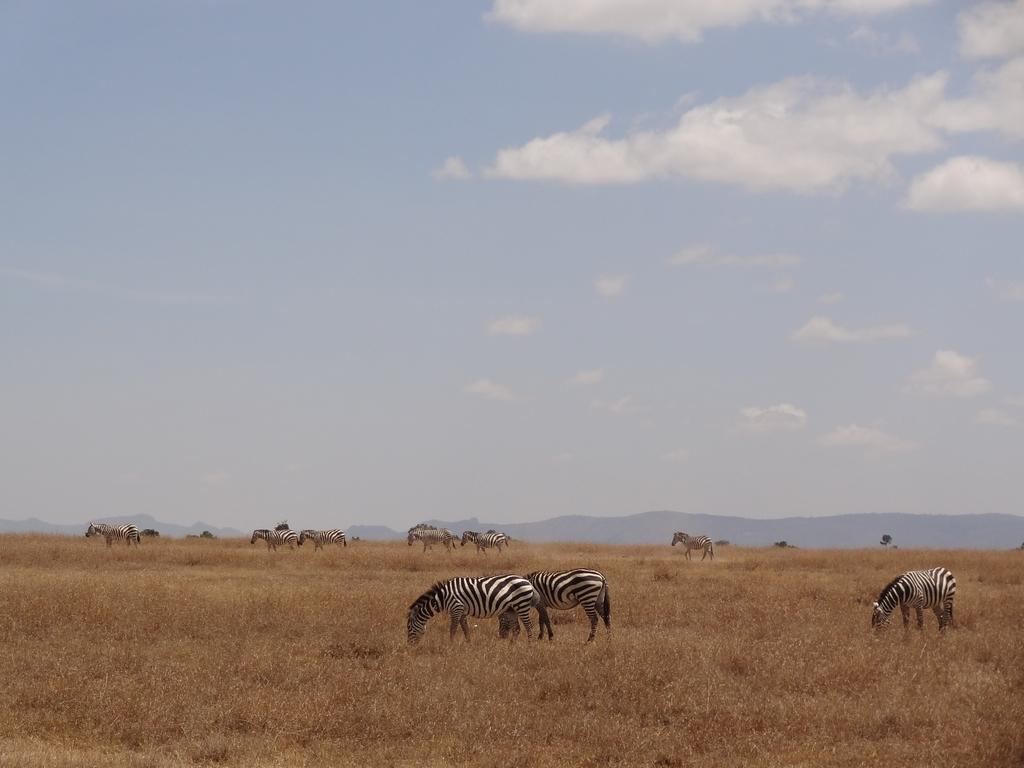What animals are present in the image? There are zebras in the image. What colors are the zebras? The zebras are in white and black color. What type of vegetation can be seen in the image? There is dry grass visible in the image. What geographical feature is present in the background of the image? There are mountains in the image. What is the color of the sky in the image? The sky is blue and white in color. What type of toys can be seen in the image? There are no toys present in the image; it features zebras, dry grass, mountains, and a blue and white sky. How much sugar is visible in the image? There is no sugar present in the image. 